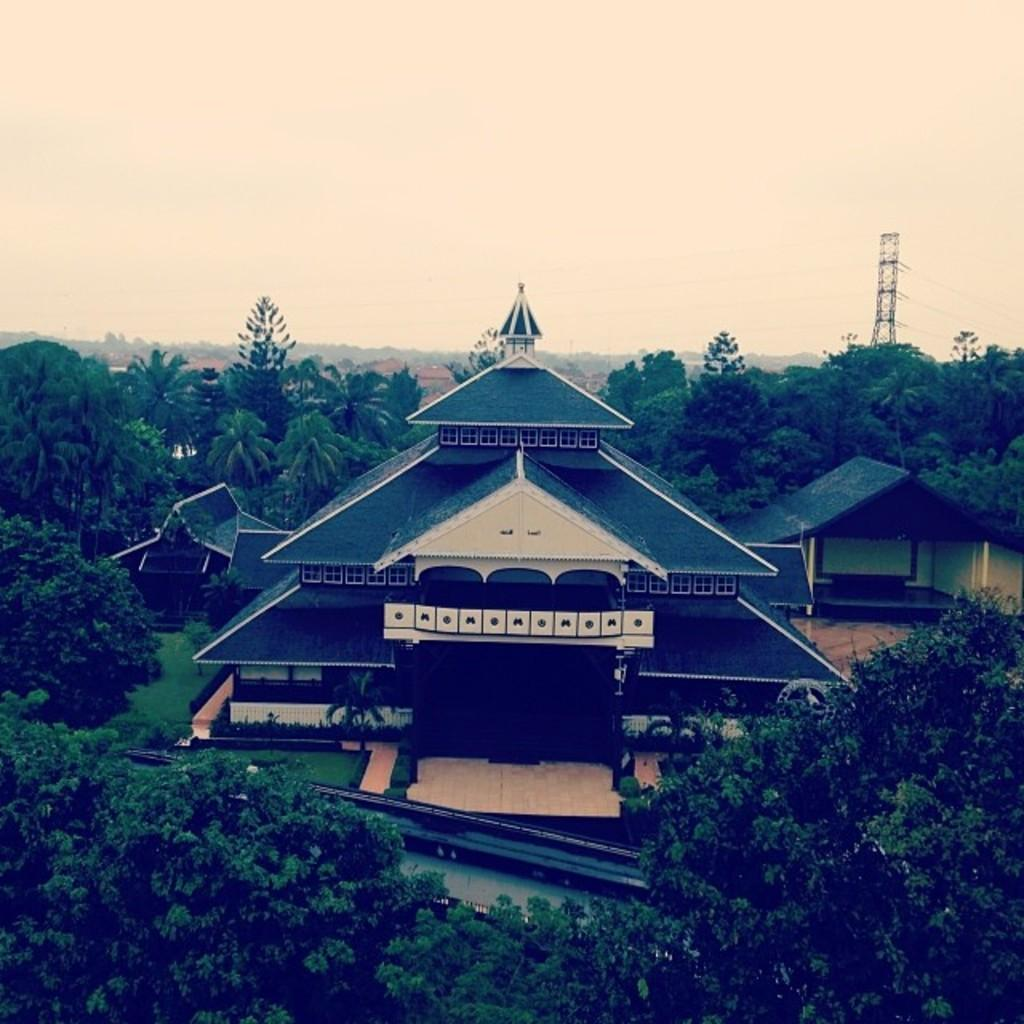What type of structure is visible in the image? There is a house in the image. What other natural elements can be seen in the image? There are trees in the image. Where is the tower located in the image? The tower is on the right side of the image. What is visible at the top of the image? The sky is visible at the top of the image. Can you tell me how many zippers are attached to the trees in the image? There are no zippers present on the trees in the image. What type of ice can be seen melting on the roof of the house in the image? There is no ice present on the roof of the house in the image. 